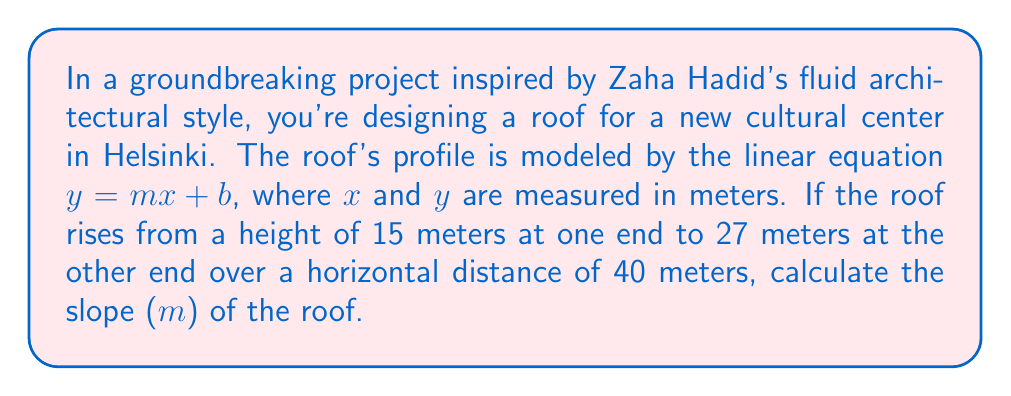Could you help me with this problem? To find the slope of the roof, we'll use the slope formula:

$$ m = \frac{y_2 - y_1}{x_2 - x_1} $$

Where:
$(x_1, y_1)$ is the first point (0, 15)
$(x_2, y_2)$ is the second point (40, 27)

Substituting these values:

$$ m = \frac{27 - 15}{40 - 0} $$

$$ m = \frac{12}{40} $$

Simplifying:

$$ m = \frac{3}{10} = 0.3 $$

The slope of the roof is 0.3, which means it rises 0.3 meters vertically for every 1 meter horizontally.
Answer: $0.3$ 